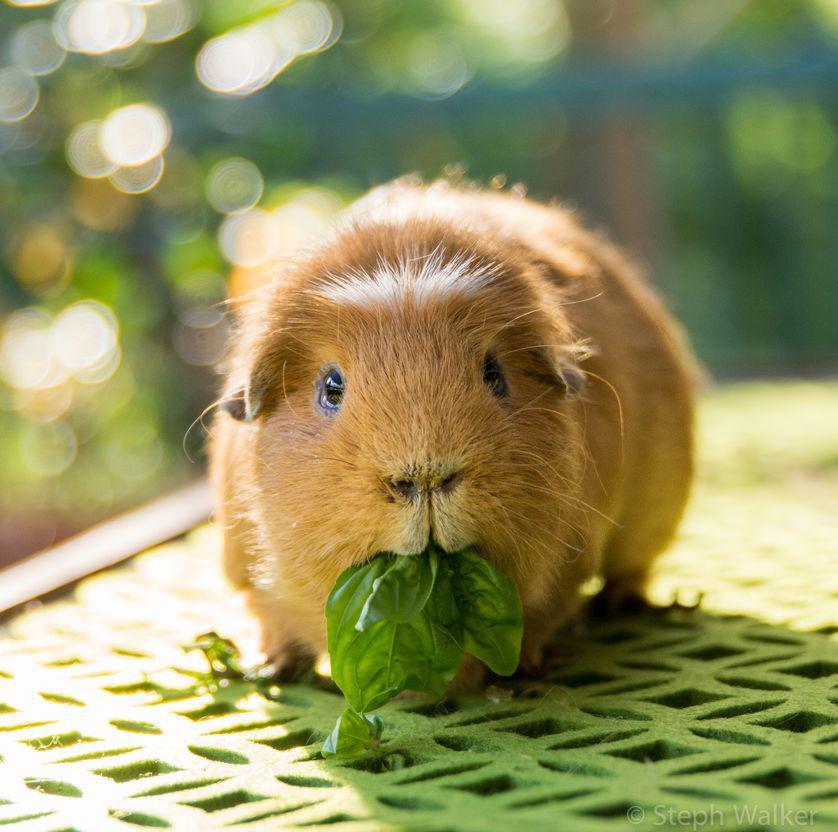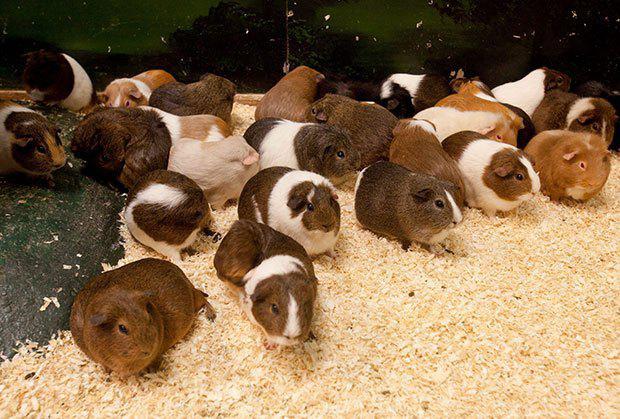The first image is the image on the left, the second image is the image on the right. Evaluate the accuracy of this statement regarding the images: "The animal in the image on the right is on a plain white background". Is it true? Answer yes or no. No. The first image is the image on the left, the second image is the image on the right. Analyze the images presented: Is the assertion "There are 2 hamsters in total" valid? Answer yes or no. No. 